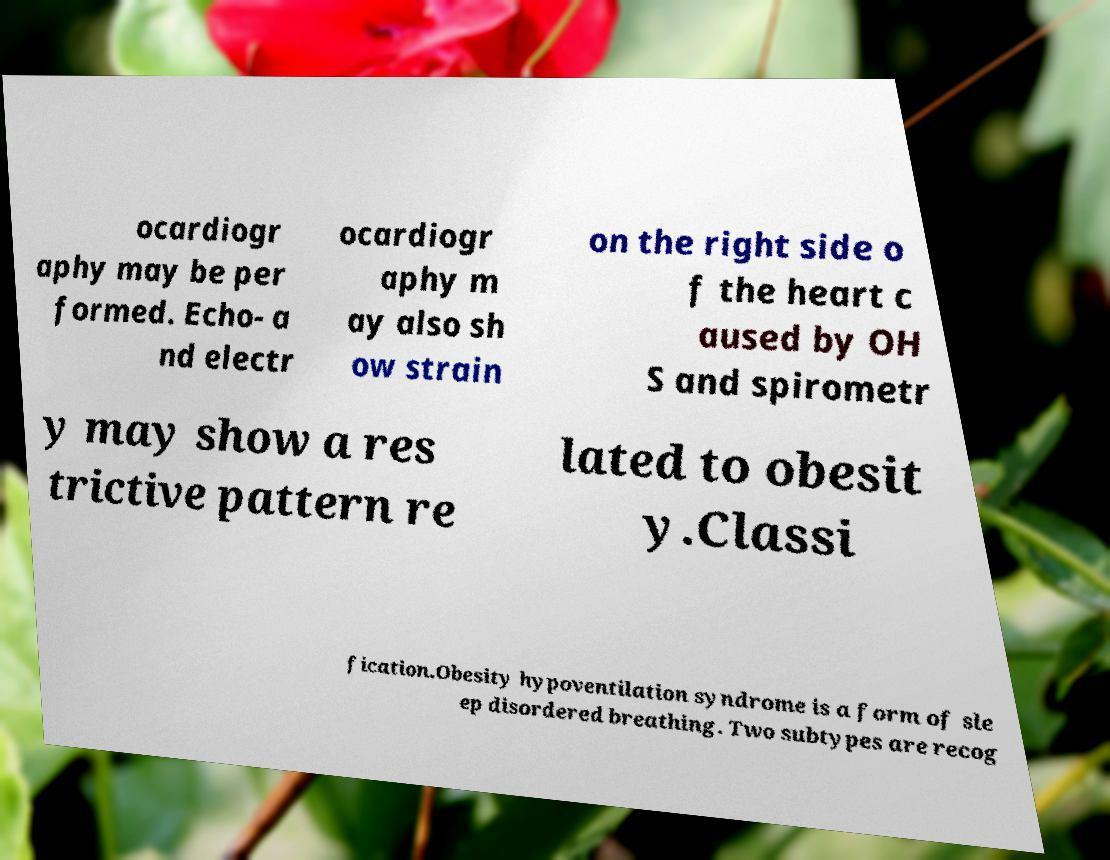For documentation purposes, I need the text within this image transcribed. Could you provide that? ocardiogr aphy may be per formed. Echo- a nd electr ocardiogr aphy m ay also sh ow strain on the right side o f the heart c aused by OH S and spirometr y may show a res trictive pattern re lated to obesit y.Classi fication.Obesity hypoventilation syndrome is a form of sle ep disordered breathing. Two subtypes are recog 